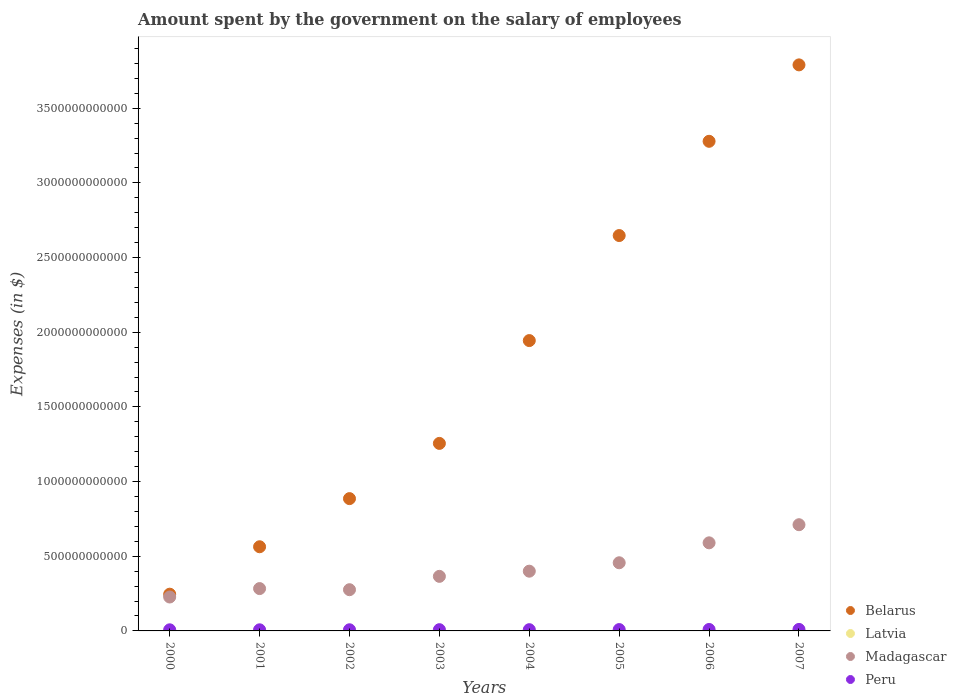How many different coloured dotlines are there?
Keep it short and to the point. 4. Is the number of dotlines equal to the number of legend labels?
Your answer should be compact. Yes. What is the amount spent on the salary of employees by the government in Peru in 2000?
Provide a succinct answer. 7.45e+09. Across all years, what is the maximum amount spent on the salary of employees by the government in Madagascar?
Offer a very short reply. 7.11e+11. Across all years, what is the minimum amount spent on the salary of employees by the government in Madagascar?
Make the answer very short. 2.27e+11. What is the total amount spent on the salary of employees by the government in Belarus in the graph?
Give a very brief answer. 1.46e+13. What is the difference between the amount spent on the salary of employees by the government in Latvia in 2001 and that in 2007?
Keep it short and to the point. -6.04e+08. What is the difference between the amount spent on the salary of employees by the government in Madagascar in 2006 and the amount spent on the salary of employees by the government in Belarus in 2007?
Give a very brief answer. -3.20e+12. What is the average amount spent on the salary of employees by the government in Peru per year?
Offer a terse response. 8.52e+09. In the year 2004, what is the difference between the amount spent on the salary of employees by the government in Madagascar and amount spent on the salary of employees by the government in Belarus?
Your answer should be very brief. -1.54e+12. What is the ratio of the amount spent on the salary of employees by the government in Peru in 2003 to that in 2005?
Your answer should be compact. 0.92. Is the amount spent on the salary of employees by the government in Peru in 2003 less than that in 2005?
Offer a very short reply. Yes. What is the difference between the highest and the second highest amount spent on the salary of employees by the government in Latvia?
Your response must be concise. 2.56e+08. What is the difference between the highest and the lowest amount spent on the salary of employees by the government in Belarus?
Provide a succinct answer. 3.54e+12. In how many years, is the amount spent on the salary of employees by the government in Belarus greater than the average amount spent on the salary of employees by the government in Belarus taken over all years?
Offer a very short reply. 4. Is it the case that in every year, the sum of the amount spent on the salary of employees by the government in Peru and amount spent on the salary of employees by the government in Latvia  is greater than the sum of amount spent on the salary of employees by the government in Belarus and amount spent on the salary of employees by the government in Madagascar?
Your response must be concise. No. Is it the case that in every year, the sum of the amount spent on the salary of employees by the government in Madagascar and amount spent on the salary of employees by the government in Peru  is greater than the amount spent on the salary of employees by the government in Belarus?
Provide a succinct answer. No. Does the amount spent on the salary of employees by the government in Peru monotonically increase over the years?
Offer a very short reply. Yes. Is the amount spent on the salary of employees by the government in Peru strictly greater than the amount spent on the salary of employees by the government in Belarus over the years?
Keep it short and to the point. No. Is the amount spent on the salary of employees by the government in Belarus strictly less than the amount spent on the salary of employees by the government in Latvia over the years?
Provide a short and direct response. No. How many years are there in the graph?
Your response must be concise. 8. What is the difference between two consecutive major ticks on the Y-axis?
Offer a very short reply. 5.00e+11. Are the values on the major ticks of Y-axis written in scientific E-notation?
Make the answer very short. No. What is the title of the graph?
Your response must be concise. Amount spent by the government on the salary of employees. Does "Morocco" appear as one of the legend labels in the graph?
Offer a terse response. No. What is the label or title of the Y-axis?
Provide a short and direct response. Expenses (in $). What is the Expenses (in $) in Belarus in 2000?
Ensure brevity in your answer.  2.46e+11. What is the Expenses (in $) of Latvia in 2000?
Offer a very short reply. 1.61e+08. What is the Expenses (in $) in Madagascar in 2000?
Give a very brief answer. 2.27e+11. What is the Expenses (in $) of Peru in 2000?
Provide a succinct answer. 7.45e+09. What is the Expenses (in $) in Belarus in 2001?
Your answer should be very brief. 5.64e+11. What is the Expenses (in $) of Latvia in 2001?
Ensure brevity in your answer.  1.73e+08. What is the Expenses (in $) of Madagascar in 2001?
Offer a terse response. 2.84e+11. What is the Expenses (in $) in Peru in 2001?
Keep it short and to the point. 7.46e+09. What is the Expenses (in $) of Belarus in 2002?
Make the answer very short. 8.86e+11. What is the Expenses (in $) of Latvia in 2002?
Make the answer very short. 2.50e+08. What is the Expenses (in $) in Madagascar in 2002?
Offer a very short reply. 2.76e+11. What is the Expenses (in $) in Peru in 2002?
Provide a short and direct response. 7.69e+09. What is the Expenses (in $) in Belarus in 2003?
Your response must be concise. 1.26e+12. What is the Expenses (in $) of Latvia in 2003?
Make the answer very short. 2.84e+08. What is the Expenses (in $) of Madagascar in 2003?
Your answer should be compact. 3.65e+11. What is the Expenses (in $) in Peru in 2003?
Provide a succinct answer. 8.31e+09. What is the Expenses (in $) of Belarus in 2004?
Offer a terse response. 1.94e+12. What is the Expenses (in $) of Latvia in 2004?
Keep it short and to the point. 3.35e+08. What is the Expenses (in $) in Madagascar in 2004?
Provide a succinct answer. 4.00e+11. What is the Expenses (in $) in Peru in 2004?
Your response must be concise. 8.36e+09. What is the Expenses (in $) of Belarus in 2005?
Keep it short and to the point. 2.65e+12. What is the Expenses (in $) of Latvia in 2005?
Provide a short and direct response. 4.13e+08. What is the Expenses (in $) of Madagascar in 2005?
Provide a succinct answer. 4.56e+11. What is the Expenses (in $) of Peru in 2005?
Offer a terse response. 9.08e+09. What is the Expenses (in $) of Belarus in 2006?
Give a very brief answer. 3.28e+12. What is the Expenses (in $) in Latvia in 2006?
Provide a short and direct response. 5.21e+08. What is the Expenses (in $) of Madagascar in 2006?
Your response must be concise. 5.90e+11. What is the Expenses (in $) in Peru in 2006?
Your response must be concise. 9.74e+09. What is the Expenses (in $) in Belarus in 2007?
Offer a terse response. 3.79e+12. What is the Expenses (in $) in Latvia in 2007?
Offer a very short reply. 7.76e+08. What is the Expenses (in $) in Madagascar in 2007?
Give a very brief answer. 7.11e+11. What is the Expenses (in $) in Peru in 2007?
Provide a succinct answer. 1.00e+1. Across all years, what is the maximum Expenses (in $) in Belarus?
Provide a succinct answer. 3.79e+12. Across all years, what is the maximum Expenses (in $) in Latvia?
Offer a terse response. 7.76e+08. Across all years, what is the maximum Expenses (in $) in Madagascar?
Your answer should be very brief. 7.11e+11. Across all years, what is the maximum Expenses (in $) of Peru?
Ensure brevity in your answer.  1.00e+1. Across all years, what is the minimum Expenses (in $) in Belarus?
Offer a terse response. 2.46e+11. Across all years, what is the minimum Expenses (in $) of Latvia?
Keep it short and to the point. 1.61e+08. Across all years, what is the minimum Expenses (in $) in Madagascar?
Provide a short and direct response. 2.27e+11. Across all years, what is the minimum Expenses (in $) of Peru?
Your response must be concise. 7.45e+09. What is the total Expenses (in $) of Belarus in the graph?
Keep it short and to the point. 1.46e+13. What is the total Expenses (in $) of Latvia in the graph?
Provide a succinct answer. 2.91e+09. What is the total Expenses (in $) of Madagascar in the graph?
Your answer should be very brief. 3.31e+12. What is the total Expenses (in $) in Peru in the graph?
Give a very brief answer. 6.81e+1. What is the difference between the Expenses (in $) in Belarus in 2000 and that in 2001?
Offer a very short reply. -3.18e+11. What is the difference between the Expenses (in $) in Latvia in 2000 and that in 2001?
Your answer should be compact. -1.14e+07. What is the difference between the Expenses (in $) of Madagascar in 2000 and that in 2001?
Offer a very short reply. -5.64e+1. What is the difference between the Expenses (in $) of Peru in 2000 and that in 2001?
Give a very brief answer. -2.60e+06. What is the difference between the Expenses (in $) of Belarus in 2000 and that in 2002?
Your response must be concise. -6.40e+11. What is the difference between the Expenses (in $) of Latvia in 2000 and that in 2002?
Your response must be concise. -8.82e+07. What is the difference between the Expenses (in $) of Madagascar in 2000 and that in 2002?
Ensure brevity in your answer.  -4.89e+1. What is the difference between the Expenses (in $) in Peru in 2000 and that in 2002?
Ensure brevity in your answer.  -2.40e+08. What is the difference between the Expenses (in $) in Belarus in 2000 and that in 2003?
Give a very brief answer. -1.01e+12. What is the difference between the Expenses (in $) in Latvia in 2000 and that in 2003?
Keep it short and to the point. -1.23e+08. What is the difference between the Expenses (in $) in Madagascar in 2000 and that in 2003?
Give a very brief answer. -1.38e+11. What is the difference between the Expenses (in $) of Peru in 2000 and that in 2003?
Your answer should be very brief. -8.55e+08. What is the difference between the Expenses (in $) in Belarus in 2000 and that in 2004?
Offer a terse response. -1.70e+12. What is the difference between the Expenses (in $) in Latvia in 2000 and that in 2004?
Ensure brevity in your answer.  -1.74e+08. What is the difference between the Expenses (in $) in Madagascar in 2000 and that in 2004?
Your response must be concise. -1.73e+11. What is the difference between the Expenses (in $) in Peru in 2000 and that in 2004?
Offer a terse response. -9.06e+08. What is the difference between the Expenses (in $) of Belarus in 2000 and that in 2005?
Your answer should be compact. -2.40e+12. What is the difference between the Expenses (in $) of Latvia in 2000 and that in 2005?
Your answer should be compact. -2.52e+08. What is the difference between the Expenses (in $) in Madagascar in 2000 and that in 2005?
Provide a short and direct response. -2.29e+11. What is the difference between the Expenses (in $) in Peru in 2000 and that in 2005?
Keep it short and to the point. -1.62e+09. What is the difference between the Expenses (in $) of Belarus in 2000 and that in 2006?
Your answer should be very brief. -3.03e+12. What is the difference between the Expenses (in $) of Latvia in 2000 and that in 2006?
Give a very brief answer. -3.60e+08. What is the difference between the Expenses (in $) of Madagascar in 2000 and that in 2006?
Give a very brief answer. -3.63e+11. What is the difference between the Expenses (in $) of Peru in 2000 and that in 2006?
Provide a short and direct response. -2.29e+09. What is the difference between the Expenses (in $) of Belarus in 2000 and that in 2007?
Ensure brevity in your answer.  -3.54e+12. What is the difference between the Expenses (in $) in Latvia in 2000 and that in 2007?
Keep it short and to the point. -6.15e+08. What is the difference between the Expenses (in $) in Madagascar in 2000 and that in 2007?
Your answer should be very brief. -4.84e+11. What is the difference between the Expenses (in $) of Peru in 2000 and that in 2007?
Provide a short and direct response. -2.59e+09. What is the difference between the Expenses (in $) of Belarus in 2001 and that in 2002?
Offer a terse response. -3.22e+11. What is the difference between the Expenses (in $) in Latvia in 2001 and that in 2002?
Provide a short and direct response. -7.69e+07. What is the difference between the Expenses (in $) of Madagascar in 2001 and that in 2002?
Ensure brevity in your answer.  7.52e+09. What is the difference between the Expenses (in $) of Peru in 2001 and that in 2002?
Make the answer very short. -2.37e+08. What is the difference between the Expenses (in $) of Belarus in 2001 and that in 2003?
Keep it short and to the point. -6.92e+11. What is the difference between the Expenses (in $) in Latvia in 2001 and that in 2003?
Your answer should be very brief. -1.11e+08. What is the difference between the Expenses (in $) of Madagascar in 2001 and that in 2003?
Your answer should be compact. -8.19e+1. What is the difference between the Expenses (in $) in Peru in 2001 and that in 2003?
Your answer should be very brief. -8.52e+08. What is the difference between the Expenses (in $) of Belarus in 2001 and that in 2004?
Your answer should be very brief. -1.38e+12. What is the difference between the Expenses (in $) in Latvia in 2001 and that in 2004?
Give a very brief answer. -1.63e+08. What is the difference between the Expenses (in $) in Madagascar in 2001 and that in 2004?
Give a very brief answer. -1.17e+11. What is the difference between the Expenses (in $) in Peru in 2001 and that in 2004?
Offer a terse response. -9.03e+08. What is the difference between the Expenses (in $) of Belarus in 2001 and that in 2005?
Provide a succinct answer. -2.08e+12. What is the difference between the Expenses (in $) in Latvia in 2001 and that in 2005?
Make the answer very short. -2.41e+08. What is the difference between the Expenses (in $) in Madagascar in 2001 and that in 2005?
Give a very brief answer. -1.73e+11. What is the difference between the Expenses (in $) in Peru in 2001 and that in 2005?
Your answer should be very brief. -1.62e+09. What is the difference between the Expenses (in $) of Belarus in 2001 and that in 2006?
Keep it short and to the point. -2.72e+12. What is the difference between the Expenses (in $) of Latvia in 2001 and that in 2006?
Provide a succinct answer. -3.48e+08. What is the difference between the Expenses (in $) of Madagascar in 2001 and that in 2006?
Keep it short and to the point. -3.06e+11. What is the difference between the Expenses (in $) of Peru in 2001 and that in 2006?
Make the answer very short. -2.29e+09. What is the difference between the Expenses (in $) in Belarus in 2001 and that in 2007?
Your response must be concise. -3.23e+12. What is the difference between the Expenses (in $) of Latvia in 2001 and that in 2007?
Make the answer very short. -6.04e+08. What is the difference between the Expenses (in $) of Madagascar in 2001 and that in 2007?
Offer a very short reply. -4.28e+11. What is the difference between the Expenses (in $) in Peru in 2001 and that in 2007?
Your answer should be compact. -2.59e+09. What is the difference between the Expenses (in $) of Belarus in 2002 and that in 2003?
Offer a terse response. -3.70e+11. What is the difference between the Expenses (in $) of Latvia in 2002 and that in 2003?
Offer a terse response. -3.44e+07. What is the difference between the Expenses (in $) of Madagascar in 2002 and that in 2003?
Keep it short and to the point. -8.94e+1. What is the difference between the Expenses (in $) in Peru in 2002 and that in 2003?
Provide a succinct answer. -6.16e+08. What is the difference between the Expenses (in $) of Belarus in 2002 and that in 2004?
Your answer should be very brief. -1.06e+12. What is the difference between the Expenses (in $) of Latvia in 2002 and that in 2004?
Give a very brief answer. -8.58e+07. What is the difference between the Expenses (in $) of Madagascar in 2002 and that in 2004?
Give a very brief answer. -1.24e+11. What is the difference between the Expenses (in $) of Peru in 2002 and that in 2004?
Make the answer very short. -6.66e+08. What is the difference between the Expenses (in $) of Belarus in 2002 and that in 2005?
Keep it short and to the point. -1.76e+12. What is the difference between the Expenses (in $) in Latvia in 2002 and that in 2005?
Your response must be concise. -1.64e+08. What is the difference between the Expenses (in $) of Madagascar in 2002 and that in 2005?
Provide a succinct answer. -1.80e+11. What is the difference between the Expenses (in $) in Peru in 2002 and that in 2005?
Your answer should be compact. -1.38e+09. What is the difference between the Expenses (in $) of Belarus in 2002 and that in 2006?
Give a very brief answer. -2.39e+12. What is the difference between the Expenses (in $) in Latvia in 2002 and that in 2006?
Offer a terse response. -2.71e+08. What is the difference between the Expenses (in $) in Madagascar in 2002 and that in 2006?
Offer a terse response. -3.14e+11. What is the difference between the Expenses (in $) in Peru in 2002 and that in 2006?
Keep it short and to the point. -2.05e+09. What is the difference between the Expenses (in $) in Belarus in 2002 and that in 2007?
Offer a terse response. -2.90e+12. What is the difference between the Expenses (in $) of Latvia in 2002 and that in 2007?
Your response must be concise. -5.27e+08. What is the difference between the Expenses (in $) of Madagascar in 2002 and that in 2007?
Provide a short and direct response. -4.35e+11. What is the difference between the Expenses (in $) of Peru in 2002 and that in 2007?
Offer a very short reply. -2.35e+09. What is the difference between the Expenses (in $) of Belarus in 2003 and that in 2004?
Ensure brevity in your answer.  -6.89e+11. What is the difference between the Expenses (in $) in Latvia in 2003 and that in 2004?
Offer a very short reply. -5.14e+07. What is the difference between the Expenses (in $) of Madagascar in 2003 and that in 2004?
Offer a very short reply. -3.46e+1. What is the difference between the Expenses (in $) of Peru in 2003 and that in 2004?
Your answer should be very brief. -5.08e+07. What is the difference between the Expenses (in $) of Belarus in 2003 and that in 2005?
Offer a very short reply. -1.39e+12. What is the difference between the Expenses (in $) of Latvia in 2003 and that in 2005?
Your answer should be very brief. -1.29e+08. What is the difference between the Expenses (in $) in Madagascar in 2003 and that in 2005?
Your response must be concise. -9.10e+1. What is the difference between the Expenses (in $) in Peru in 2003 and that in 2005?
Keep it short and to the point. -7.69e+08. What is the difference between the Expenses (in $) of Belarus in 2003 and that in 2006?
Make the answer very short. -2.02e+12. What is the difference between the Expenses (in $) of Latvia in 2003 and that in 2006?
Provide a short and direct response. -2.37e+08. What is the difference between the Expenses (in $) of Madagascar in 2003 and that in 2006?
Offer a very short reply. -2.24e+11. What is the difference between the Expenses (in $) in Peru in 2003 and that in 2006?
Keep it short and to the point. -1.43e+09. What is the difference between the Expenses (in $) in Belarus in 2003 and that in 2007?
Make the answer very short. -2.53e+12. What is the difference between the Expenses (in $) in Latvia in 2003 and that in 2007?
Ensure brevity in your answer.  -4.92e+08. What is the difference between the Expenses (in $) in Madagascar in 2003 and that in 2007?
Give a very brief answer. -3.46e+11. What is the difference between the Expenses (in $) of Peru in 2003 and that in 2007?
Provide a succinct answer. -1.74e+09. What is the difference between the Expenses (in $) of Belarus in 2004 and that in 2005?
Ensure brevity in your answer.  -7.03e+11. What is the difference between the Expenses (in $) in Latvia in 2004 and that in 2005?
Provide a short and direct response. -7.79e+07. What is the difference between the Expenses (in $) of Madagascar in 2004 and that in 2005?
Ensure brevity in your answer.  -5.64e+1. What is the difference between the Expenses (in $) in Peru in 2004 and that in 2005?
Make the answer very short. -7.18e+08. What is the difference between the Expenses (in $) of Belarus in 2004 and that in 2006?
Offer a very short reply. -1.33e+12. What is the difference between the Expenses (in $) in Latvia in 2004 and that in 2006?
Provide a short and direct response. -1.86e+08. What is the difference between the Expenses (in $) of Madagascar in 2004 and that in 2006?
Offer a very short reply. -1.90e+11. What is the difference between the Expenses (in $) of Peru in 2004 and that in 2006?
Ensure brevity in your answer.  -1.38e+09. What is the difference between the Expenses (in $) of Belarus in 2004 and that in 2007?
Your answer should be compact. -1.85e+12. What is the difference between the Expenses (in $) in Latvia in 2004 and that in 2007?
Make the answer very short. -4.41e+08. What is the difference between the Expenses (in $) of Madagascar in 2004 and that in 2007?
Provide a short and direct response. -3.11e+11. What is the difference between the Expenses (in $) of Peru in 2004 and that in 2007?
Your response must be concise. -1.69e+09. What is the difference between the Expenses (in $) in Belarus in 2005 and that in 2006?
Keep it short and to the point. -6.31e+11. What is the difference between the Expenses (in $) in Latvia in 2005 and that in 2006?
Your answer should be very brief. -1.08e+08. What is the difference between the Expenses (in $) of Madagascar in 2005 and that in 2006?
Your response must be concise. -1.34e+11. What is the difference between the Expenses (in $) in Peru in 2005 and that in 2006?
Your response must be concise. -6.66e+08. What is the difference between the Expenses (in $) of Belarus in 2005 and that in 2007?
Your response must be concise. -1.14e+12. What is the difference between the Expenses (in $) in Latvia in 2005 and that in 2007?
Ensure brevity in your answer.  -3.63e+08. What is the difference between the Expenses (in $) of Madagascar in 2005 and that in 2007?
Offer a very short reply. -2.55e+11. What is the difference between the Expenses (in $) in Peru in 2005 and that in 2007?
Offer a very short reply. -9.68e+08. What is the difference between the Expenses (in $) of Belarus in 2006 and that in 2007?
Make the answer very short. -5.12e+11. What is the difference between the Expenses (in $) of Latvia in 2006 and that in 2007?
Your answer should be very brief. -2.56e+08. What is the difference between the Expenses (in $) of Madagascar in 2006 and that in 2007?
Your answer should be compact. -1.21e+11. What is the difference between the Expenses (in $) of Peru in 2006 and that in 2007?
Your answer should be compact. -3.02e+08. What is the difference between the Expenses (in $) of Belarus in 2000 and the Expenses (in $) of Latvia in 2001?
Your answer should be very brief. 2.46e+11. What is the difference between the Expenses (in $) of Belarus in 2000 and the Expenses (in $) of Madagascar in 2001?
Your answer should be compact. -3.75e+1. What is the difference between the Expenses (in $) in Belarus in 2000 and the Expenses (in $) in Peru in 2001?
Offer a very short reply. 2.39e+11. What is the difference between the Expenses (in $) in Latvia in 2000 and the Expenses (in $) in Madagascar in 2001?
Your response must be concise. -2.83e+11. What is the difference between the Expenses (in $) in Latvia in 2000 and the Expenses (in $) in Peru in 2001?
Offer a very short reply. -7.29e+09. What is the difference between the Expenses (in $) in Madagascar in 2000 and the Expenses (in $) in Peru in 2001?
Offer a terse response. 2.20e+11. What is the difference between the Expenses (in $) of Belarus in 2000 and the Expenses (in $) of Latvia in 2002?
Your answer should be very brief. 2.46e+11. What is the difference between the Expenses (in $) of Belarus in 2000 and the Expenses (in $) of Madagascar in 2002?
Ensure brevity in your answer.  -3.00e+1. What is the difference between the Expenses (in $) of Belarus in 2000 and the Expenses (in $) of Peru in 2002?
Ensure brevity in your answer.  2.38e+11. What is the difference between the Expenses (in $) of Latvia in 2000 and the Expenses (in $) of Madagascar in 2002?
Ensure brevity in your answer.  -2.76e+11. What is the difference between the Expenses (in $) in Latvia in 2000 and the Expenses (in $) in Peru in 2002?
Provide a short and direct response. -7.53e+09. What is the difference between the Expenses (in $) in Madagascar in 2000 and the Expenses (in $) in Peru in 2002?
Give a very brief answer. 2.19e+11. What is the difference between the Expenses (in $) of Belarus in 2000 and the Expenses (in $) of Latvia in 2003?
Offer a terse response. 2.46e+11. What is the difference between the Expenses (in $) of Belarus in 2000 and the Expenses (in $) of Madagascar in 2003?
Ensure brevity in your answer.  -1.19e+11. What is the difference between the Expenses (in $) in Belarus in 2000 and the Expenses (in $) in Peru in 2003?
Offer a terse response. 2.38e+11. What is the difference between the Expenses (in $) in Latvia in 2000 and the Expenses (in $) in Madagascar in 2003?
Offer a terse response. -3.65e+11. What is the difference between the Expenses (in $) in Latvia in 2000 and the Expenses (in $) in Peru in 2003?
Provide a succinct answer. -8.15e+09. What is the difference between the Expenses (in $) of Madagascar in 2000 and the Expenses (in $) of Peru in 2003?
Provide a succinct answer. 2.19e+11. What is the difference between the Expenses (in $) of Belarus in 2000 and the Expenses (in $) of Latvia in 2004?
Ensure brevity in your answer.  2.46e+11. What is the difference between the Expenses (in $) in Belarus in 2000 and the Expenses (in $) in Madagascar in 2004?
Ensure brevity in your answer.  -1.54e+11. What is the difference between the Expenses (in $) in Belarus in 2000 and the Expenses (in $) in Peru in 2004?
Provide a succinct answer. 2.38e+11. What is the difference between the Expenses (in $) in Latvia in 2000 and the Expenses (in $) in Madagascar in 2004?
Ensure brevity in your answer.  -4.00e+11. What is the difference between the Expenses (in $) of Latvia in 2000 and the Expenses (in $) of Peru in 2004?
Your answer should be very brief. -8.20e+09. What is the difference between the Expenses (in $) in Madagascar in 2000 and the Expenses (in $) in Peru in 2004?
Provide a succinct answer. 2.19e+11. What is the difference between the Expenses (in $) of Belarus in 2000 and the Expenses (in $) of Latvia in 2005?
Provide a short and direct response. 2.46e+11. What is the difference between the Expenses (in $) of Belarus in 2000 and the Expenses (in $) of Madagascar in 2005?
Your answer should be compact. -2.10e+11. What is the difference between the Expenses (in $) in Belarus in 2000 and the Expenses (in $) in Peru in 2005?
Keep it short and to the point. 2.37e+11. What is the difference between the Expenses (in $) in Latvia in 2000 and the Expenses (in $) in Madagascar in 2005?
Offer a very short reply. -4.56e+11. What is the difference between the Expenses (in $) of Latvia in 2000 and the Expenses (in $) of Peru in 2005?
Ensure brevity in your answer.  -8.92e+09. What is the difference between the Expenses (in $) of Madagascar in 2000 and the Expenses (in $) of Peru in 2005?
Offer a terse response. 2.18e+11. What is the difference between the Expenses (in $) of Belarus in 2000 and the Expenses (in $) of Latvia in 2006?
Keep it short and to the point. 2.45e+11. What is the difference between the Expenses (in $) in Belarus in 2000 and the Expenses (in $) in Madagascar in 2006?
Offer a terse response. -3.44e+11. What is the difference between the Expenses (in $) in Belarus in 2000 and the Expenses (in $) in Peru in 2006?
Make the answer very short. 2.36e+11. What is the difference between the Expenses (in $) in Latvia in 2000 and the Expenses (in $) in Madagascar in 2006?
Offer a very short reply. -5.90e+11. What is the difference between the Expenses (in $) of Latvia in 2000 and the Expenses (in $) of Peru in 2006?
Your response must be concise. -9.58e+09. What is the difference between the Expenses (in $) of Madagascar in 2000 and the Expenses (in $) of Peru in 2006?
Keep it short and to the point. 2.17e+11. What is the difference between the Expenses (in $) in Belarus in 2000 and the Expenses (in $) in Latvia in 2007?
Your response must be concise. 2.45e+11. What is the difference between the Expenses (in $) in Belarus in 2000 and the Expenses (in $) in Madagascar in 2007?
Offer a terse response. -4.65e+11. What is the difference between the Expenses (in $) of Belarus in 2000 and the Expenses (in $) of Peru in 2007?
Offer a very short reply. 2.36e+11. What is the difference between the Expenses (in $) of Latvia in 2000 and the Expenses (in $) of Madagascar in 2007?
Your answer should be compact. -7.11e+11. What is the difference between the Expenses (in $) of Latvia in 2000 and the Expenses (in $) of Peru in 2007?
Provide a succinct answer. -9.88e+09. What is the difference between the Expenses (in $) in Madagascar in 2000 and the Expenses (in $) in Peru in 2007?
Provide a short and direct response. 2.17e+11. What is the difference between the Expenses (in $) of Belarus in 2001 and the Expenses (in $) of Latvia in 2002?
Offer a terse response. 5.63e+11. What is the difference between the Expenses (in $) of Belarus in 2001 and the Expenses (in $) of Madagascar in 2002?
Your response must be concise. 2.88e+11. What is the difference between the Expenses (in $) in Belarus in 2001 and the Expenses (in $) in Peru in 2002?
Provide a short and direct response. 5.56e+11. What is the difference between the Expenses (in $) in Latvia in 2001 and the Expenses (in $) in Madagascar in 2002?
Your response must be concise. -2.76e+11. What is the difference between the Expenses (in $) of Latvia in 2001 and the Expenses (in $) of Peru in 2002?
Make the answer very short. -7.52e+09. What is the difference between the Expenses (in $) of Madagascar in 2001 and the Expenses (in $) of Peru in 2002?
Give a very brief answer. 2.76e+11. What is the difference between the Expenses (in $) in Belarus in 2001 and the Expenses (in $) in Latvia in 2003?
Offer a terse response. 5.63e+11. What is the difference between the Expenses (in $) in Belarus in 2001 and the Expenses (in $) in Madagascar in 2003?
Offer a very short reply. 1.98e+11. What is the difference between the Expenses (in $) of Belarus in 2001 and the Expenses (in $) of Peru in 2003?
Offer a very short reply. 5.55e+11. What is the difference between the Expenses (in $) in Latvia in 2001 and the Expenses (in $) in Madagascar in 2003?
Your response must be concise. -3.65e+11. What is the difference between the Expenses (in $) in Latvia in 2001 and the Expenses (in $) in Peru in 2003?
Give a very brief answer. -8.14e+09. What is the difference between the Expenses (in $) of Madagascar in 2001 and the Expenses (in $) of Peru in 2003?
Make the answer very short. 2.75e+11. What is the difference between the Expenses (in $) in Belarus in 2001 and the Expenses (in $) in Latvia in 2004?
Make the answer very short. 5.63e+11. What is the difference between the Expenses (in $) of Belarus in 2001 and the Expenses (in $) of Madagascar in 2004?
Offer a terse response. 1.64e+11. What is the difference between the Expenses (in $) of Belarus in 2001 and the Expenses (in $) of Peru in 2004?
Your answer should be very brief. 5.55e+11. What is the difference between the Expenses (in $) in Latvia in 2001 and the Expenses (in $) in Madagascar in 2004?
Make the answer very short. -4.00e+11. What is the difference between the Expenses (in $) of Latvia in 2001 and the Expenses (in $) of Peru in 2004?
Provide a short and direct response. -8.19e+09. What is the difference between the Expenses (in $) in Madagascar in 2001 and the Expenses (in $) in Peru in 2004?
Keep it short and to the point. 2.75e+11. What is the difference between the Expenses (in $) in Belarus in 2001 and the Expenses (in $) in Latvia in 2005?
Provide a succinct answer. 5.63e+11. What is the difference between the Expenses (in $) of Belarus in 2001 and the Expenses (in $) of Madagascar in 2005?
Keep it short and to the point. 1.07e+11. What is the difference between the Expenses (in $) in Belarus in 2001 and the Expenses (in $) in Peru in 2005?
Your answer should be compact. 5.55e+11. What is the difference between the Expenses (in $) in Latvia in 2001 and the Expenses (in $) in Madagascar in 2005?
Keep it short and to the point. -4.56e+11. What is the difference between the Expenses (in $) in Latvia in 2001 and the Expenses (in $) in Peru in 2005?
Give a very brief answer. -8.90e+09. What is the difference between the Expenses (in $) of Madagascar in 2001 and the Expenses (in $) of Peru in 2005?
Ensure brevity in your answer.  2.74e+11. What is the difference between the Expenses (in $) in Belarus in 2001 and the Expenses (in $) in Latvia in 2006?
Provide a short and direct response. 5.63e+11. What is the difference between the Expenses (in $) of Belarus in 2001 and the Expenses (in $) of Madagascar in 2006?
Your answer should be compact. -2.63e+1. What is the difference between the Expenses (in $) in Belarus in 2001 and the Expenses (in $) in Peru in 2006?
Offer a very short reply. 5.54e+11. What is the difference between the Expenses (in $) in Latvia in 2001 and the Expenses (in $) in Madagascar in 2006?
Provide a succinct answer. -5.90e+11. What is the difference between the Expenses (in $) of Latvia in 2001 and the Expenses (in $) of Peru in 2006?
Provide a short and direct response. -9.57e+09. What is the difference between the Expenses (in $) of Madagascar in 2001 and the Expenses (in $) of Peru in 2006?
Offer a terse response. 2.74e+11. What is the difference between the Expenses (in $) of Belarus in 2001 and the Expenses (in $) of Latvia in 2007?
Provide a short and direct response. 5.63e+11. What is the difference between the Expenses (in $) of Belarus in 2001 and the Expenses (in $) of Madagascar in 2007?
Provide a short and direct response. -1.48e+11. What is the difference between the Expenses (in $) in Belarus in 2001 and the Expenses (in $) in Peru in 2007?
Keep it short and to the point. 5.54e+11. What is the difference between the Expenses (in $) in Latvia in 2001 and the Expenses (in $) in Madagascar in 2007?
Make the answer very short. -7.11e+11. What is the difference between the Expenses (in $) in Latvia in 2001 and the Expenses (in $) in Peru in 2007?
Your answer should be compact. -9.87e+09. What is the difference between the Expenses (in $) in Madagascar in 2001 and the Expenses (in $) in Peru in 2007?
Ensure brevity in your answer.  2.73e+11. What is the difference between the Expenses (in $) in Belarus in 2002 and the Expenses (in $) in Latvia in 2003?
Give a very brief answer. 8.86e+11. What is the difference between the Expenses (in $) of Belarus in 2002 and the Expenses (in $) of Madagascar in 2003?
Make the answer very short. 5.21e+11. What is the difference between the Expenses (in $) of Belarus in 2002 and the Expenses (in $) of Peru in 2003?
Your answer should be very brief. 8.78e+11. What is the difference between the Expenses (in $) in Latvia in 2002 and the Expenses (in $) in Madagascar in 2003?
Your answer should be very brief. -3.65e+11. What is the difference between the Expenses (in $) in Latvia in 2002 and the Expenses (in $) in Peru in 2003?
Give a very brief answer. -8.06e+09. What is the difference between the Expenses (in $) in Madagascar in 2002 and the Expenses (in $) in Peru in 2003?
Offer a terse response. 2.68e+11. What is the difference between the Expenses (in $) in Belarus in 2002 and the Expenses (in $) in Latvia in 2004?
Keep it short and to the point. 8.86e+11. What is the difference between the Expenses (in $) of Belarus in 2002 and the Expenses (in $) of Madagascar in 2004?
Give a very brief answer. 4.86e+11. What is the difference between the Expenses (in $) of Belarus in 2002 and the Expenses (in $) of Peru in 2004?
Give a very brief answer. 8.78e+11. What is the difference between the Expenses (in $) in Latvia in 2002 and the Expenses (in $) in Madagascar in 2004?
Offer a very short reply. -4.00e+11. What is the difference between the Expenses (in $) in Latvia in 2002 and the Expenses (in $) in Peru in 2004?
Ensure brevity in your answer.  -8.11e+09. What is the difference between the Expenses (in $) of Madagascar in 2002 and the Expenses (in $) of Peru in 2004?
Your response must be concise. 2.68e+11. What is the difference between the Expenses (in $) of Belarus in 2002 and the Expenses (in $) of Latvia in 2005?
Provide a short and direct response. 8.86e+11. What is the difference between the Expenses (in $) in Belarus in 2002 and the Expenses (in $) in Madagascar in 2005?
Provide a short and direct response. 4.30e+11. What is the difference between the Expenses (in $) of Belarus in 2002 and the Expenses (in $) of Peru in 2005?
Provide a short and direct response. 8.77e+11. What is the difference between the Expenses (in $) of Latvia in 2002 and the Expenses (in $) of Madagascar in 2005?
Offer a very short reply. -4.56e+11. What is the difference between the Expenses (in $) in Latvia in 2002 and the Expenses (in $) in Peru in 2005?
Offer a terse response. -8.83e+09. What is the difference between the Expenses (in $) in Madagascar in 2002 and the Expenses (in $) in Peru in 2005?
Give a very brief answer. 2.67e+11. What is the difference between the Expenses (in $) in Belarus in 2002 and the Expenses (in $) in Latvia in 2006?
Provide a short and direct response. 8.85e+11. What is the difference between the Expenses (in $) of Belarus in 2002 and the Expenses (in $) of Madagascar in 2006?
Make the answer very short. 2.96e+11. What is the difference between the Expenses (in $) in Belarus in 2002 and the Expenses (in $) in Peru in 2006?
Keep it short and to the point. 8.76e+11. What is the difference between the Expenses (in $) in Latvia in 2002 and the Expenses (in $) in Madagascar in 2006?
Your answer should be compact. -5.90e+11. What is the difference between the Expenses (in $) in Latvia in 2002 and the Expenses (in $) in Peru in 2006?
Your answer should be compact. -9.49e+09. What is the difference between the Expenses (in $) of Madagascar in 2002 and the Expenses (in $) of Peru in 2006?
Ensure brevity in your answer.  2.66e+11. What is the difference between the Expenses (in $) in Belarus in 2002 and the Expenses (in $) in Latvia in 2007?
Your answer should be compact. 8.85e+11. What is the difference between the Expenses (in $) of Belarus in 2002 and the Expenses (in $) of Madagascar in 2007?
Make the answer very short. 1.75e+11. What is the difference between the Expenses (in $) of Belarus in 2002 and the Expenses (in $) of Peru in 2007?
Keep it short and to the point. 8.76e+11. What is the difference between the Expenses (in $) of Latvia in 2002 and the Expenses (in $) of Madagascar in 2007?
Keep it short and to the point. -7.11e+11. What is the difference between the Expenses (in $) in Latvia in 2002 and the Expenses (in $) in Peru in 2007?
Ensure brevity in your answer.  -9.80e+09. What is the difference between the Expenses (in $) in Madagascar in 2002 and the Expenses (in $) in Peru in 2007?
Provide a short and direct response. 2.66e+11. What is the difference between the Expenses (in $) in Belarus in 2003 and the Expenses (in $) in Latvia in 2004?
Give a very brief answer. 1.26e+12. What is the difference between the Expenses (in $) in Belarus in 2003 and the Expenses (in $) in Madagascar in 2004?
Keep it short and to the point. 8.56e+11. What is the difference between the Expenses (in $) in Belarus in 2003 and the Expenses (in $) in Peru in 2004?
Provide a short and direct response. 1.25e+12. What is the difference between the Expenses (in $) of Latvia in 2003 and the Expenses (in $) of Madagascar in 2004?
Make the answer very short. -4.00e+11. What is the difference between the Expenses (in $) of Latvia in 2003 and the Expenses (in $) of Peru in 2004?
Your answer should be very brief. -8.08e+09. What is the difference between the Expenses (in $) in Madagascar in 2003 and the Expenses (in $) in Peru in 2004?
Make the answer very short. 3.57e+11. What is the difference between the Expenses (in $) of Belarus in 2003 and the Expenses (in $) of Latvia in 2005?
Give a very brief answer. 1.26e+12. What is the difference between the Expenses (in $) in Belarus in 2003 and the Expenses (in $) in Madagascar in 2005?
Ensure brevity in your answer.  7.99e+11. What is the difference between the Expenses (in $) of Belarus in 2003 and the Expenses (in $) of Peru in 2005?
Offer a terse response. 1.25e+12. What is the difference between the Expenses (in $) of Latvia in 2003 and the Expenses (in $) of Madagascar in 2005?
Keep it short and to the point. -4.56e+11. What is the difference between the Expenses (in $) of Latvia in 2003 and the Expenses (in $) of Peru in 2005?
Offer a terse response. -8.79e+09. What is the difference between the Expenses (in $) of Madagascar in 2003 and the Expenses (in $) of Peru in 2005?
Provide a short and direct response. 3.56e+11. What is the difference between the Expenses (in $) of Belarus in 2003 and the Expenses (in $) of Latvia in 2006?
Provide a short and direct response. 1.26e+12. What is the difference between the Expenses (in $) in Belarus in 2003 and the Expenses (in $) in Madagascar in 2006?
Provide a short and direct response. 6.66e+11. What is the difference between the Expenses (in $) in Belarus in 2003 and the Expenses (in $) in Peru in 2006?
Provide a succinct answer. 1.25e+12. What is the difference between the Expenses (in $) of Latvia in 2003 and the Expenses (in $) of Madagascar in 2006?
Make the answer very short. -5.90e+11. What is the difference between the Expenses (in $) in Latvia in 2003 and the Expenses (in $) in Peru in 2006?
Your answer should be very brief. -9.46e+09. What is the difference between the Expenses (in $) of Madagascar in 2003 and the Expenses (in $) of Peru in 2006?
Your response must be concise. 3.56e+11. What is the difference between the Expenses (in $) of Belarus in 2003 and the Expenses (in $) of Latvia in 2007?
Provide a succinct answer. 1.25e+12. What is the difference between the Expenses (in $) of Belarus in 2003 and the Expenses (in $) of Madagascar in 2007?
Your answer should be compact. 5.45e+11. What is the difference between the Expenses (in $) in Belarus in 2003 and the Expenses (in $) in Peru in 2007?
Offer a terse response. 1.25e+12. What is the difference between the Expenses (in $) in Latvia in 2003 and the Expenses (in $) in Madagascar in 2007?
Your response must be concise. -7.11e+11. What is the difference between the Expenses (in $) of Latvia in 2003 and the Expenses (in $) of Peru in 2007?
Make the answer very short. -9.76e+09. What is the difference between the Expenses (in $) in Madagascar in 2003 and the Expenses (in $) in Peru in 2007?
Keep it short and to the point. 3.55e+11. What is the difference between the Expenses (in $) in Belarus in 2004 and the Expenses (in $) in Latvia in 2005?
Offer a terse response. 1.94e+12. What is the difference between the Expenses (in $) of Belarus in 2004 and the Expenses (in $) of Madagascar in 2005?
Keep it short and to the point. 1.49e+12. What is the difference between the Expenses (in $) in Belarus in 2004 and the Expenses (in $) in Peru in 2005?
Your answer should be compact. 1.94e+12. What is the difference between the Expenses (in $) of Latvia in 2004 and the Expenses (in $) of Madagascar in 2005?
Your answer should be very brief. -4.56e+11. What is the difference between the Expenses (in $) of Latvia in 2004 and the Expenses (in $) of Peru in 2005?
Keep it short and to the point. -8.74e+09. What is the difference between the Expenses (in $) of Madagascar in 2004 and the Expenses (in $) of Peru in 2005?
Give a very brief answer. 3.91e+11. What is the difference between the Expenses (in $) of Belarus in 2004 and the Expenses (in $) of Latvia in 2006?
Your answer should be compact. 1.94e+12. What is the difference between the Expenses (in $) in Belarus in 2004 and the Expenses (in $) in Madagascar in 2006?
Your answer should be compact. 1.35e+12. What is the difference between the Expenses (in $) of Belarus in 2004 and the Expenses (in $) of Peru in 2006?
Keep it short and to the point. 1.93e+12. What is the difference between the Expenses (in $) of Latvia in 2004 and the Expenses (in $) of Madagascar in 2006?
Your response must be concise. -5.90e+11. What is the difference between the Expenses (in $) of Latvia in 2004 and the Expenses (in $) of Peru in 2006?
Provide a short and direct response. -9.41e+09. What is the difference between the Expenses (in $) in Madagascar in 2004 and the Expenses (in $) in Peru in 2006?
Offer a terse response. 3.90e+11. What is the difference between the Expenses (in $) of Belarus in 2004 and the Expenses (in $) of Latvia in 2007?
Provide a short and direct response. 1.94e+12. What is the difference between the Expenses (in $) of Belarus in 2004 and the Expenses (in $) of Madagascar in 2007?
Ensure brevity in your answer.  1.23e+12. What is the difference between the Expenses (in $) of Belarus in 2004 and the Expenses (in $) of Peru in 2007?
Offer a terse response. 1.93e+12. What is the difference between the Expenses (in $) of Latvia in 2004 and the Expenses (in $) of Madagascar in 2007?
Offer a very short reply. -7.11e+11. What is the difference between the Expenses (in $) in Latvia in 2004 and the Expenses (in $) in Peru in 2007?
Your response must be concise. -9.71e+09. What is the difference between the Expenses (in $) of Madagascar in 2004 and the Expenses (in $) of Peru in 2007?
Keep it short and to the point. 3.90e+11. What is the difference between the Expenses (in $) in Belarus in 2005 and the Expenses (in $) in Latvia in 2006?
Provide a short and direct response. 2.65e+12. What is the difference between the Expenses (in $) in Belarus in 2005 and the Expenses (in $) in Madagascar in 2006?
Give a very brief answer. 2.06e+12. What is the difference between the Expenses (in $) in Belarus in 2005 and the Expenses (in $) in Peru in 2006?
Ensure brevity in your answer.  2.64e+12. What is the difference between the Expenses (in $) of Latvia in 2005 and the Expenses (in $) of Madagascar in 2006?
Your response must be concise. -5.89e+11. What is the difference between the Expenses (in $) of Latvia in 2005 and the Expenses (in $) of Peru in 2006?
Ensure brevity in your answer.  -9.33e+09. What is the difference between the Expenses (in $) in Madagascar in 2005 and the Expenses (in $) in Peru in 2006?
Give a very brief answer. 4.47e+11. What is the difference between the Expenses (in $) of Belarus in 2005 and the Expenses (in $) of Latvia in 2007?
Your answer should be very brief. 2.65e+12. What is the difference between the Expenses (in $) in Belarus in 2005 and the Expenses (in $) in Madagascar in 2007?
Make the answer very short. 1.94e+12. What is the difference between the Expenses (in $) of Belarus in 2005 and the Expenses (in $) of Peru in 2007?
Ensure brevity in your answer.  2.64e+12. What is the difference between the Expenses (in $) of Latvia in 2005 and the Expenses (in $) of Madagascar in 2007?
Ensure brevity in your answer.  -7.11e+11. What is the difference between the Expenses (in $) of Latvia in 2005 and the Expenses (in $) of Peru in 2007?
Your answer should be very brief. -9.63e+09. What is the difference between the Expenses (in $) in Madagascar in 2005 and the Expenses (in $) in Peru in 2007?
Give a very brief answer. 4.46e+11. What is the difference between the Expenses (in $) of Belarus in 2006 and the Expenses (in $) of Latvia in 2007?
Keep it short and to the point. 3.28e+12. What is the difference between the Expenses (in $) in Belarus in 2006 and the Expenses (in $) in Madagascar in 2007?
Provide a succinct answer. 2.57e+12. What is the difference between the Expenses (in $) in Belarus in 2006 and the Expenses (in $) in Peru in 2007?
Ensure brevity in your answer.  3.27e+12. What is the difference between the Expenses (in $) of Latvia in 2006 and the Expenses (in $) of Madagascar in 2007?
Offer a terse response. -7.11e+11. What is the difference between the Expenses (in $) of Latvia in 2006 and the Expenses (in $) of Peru in 2007?
Offer a terse response. -9.52e+09. What is the difference between the Expenses (in $) of Madagascar in 2006 and the Expenses (in $) of Peru in 2007?
Offer a terse response. 5.80e+11. What is the average Expenses (in $) in Belarus per year?
Provide a short and direct response. 1.83e+12. What is the average Expenses (in $) of Latvia per year?
Your response must be concise. 3.64e+08. What is the average Expenses (in $) of Madagascar per year?
Offer a very short reply. 4.14e+11. What is the average Expenses (in $) of Peru per year?
Offer a terse response. 8.52e+09. In the year 2000, what is the difference between the Expenses (in $) of Belarus and Expenses (in $) of Latvia?
Offer a terse response. 2.46e+11. In the year 2000, what is the difference between the Expenses (in $) in Belarus and Expenses (in $) in Madagascar?
Your answer should be very brief. 1.89e+1. In the year 2000, what is the difference between the Expenses (in $) in Belarus and Expenses (in $) in Peru?
Keep it short and to the point. 2.39e+11. In the year 2000, what is the difference between the Expenses (in $) of Latvia and Expenses (in $) of Madagascar?
Provide a short and direct response. -2.27e+11. In the year 2000, what is the difference between the Expenses (in $) of Latvia and Expenses (in $) of Peru?
Your response must be concise. -7.29e+09. In the year 2000, what is the difference between the Expenses (in $) of Madagascar and Expenses (in $) of Peru?
Your answer should be compact. 2.20e+11. In the year 2001, what is the difference between the Expenses (in $) of Belarus and Expenses (in $) of Latvia?
Give a very brief answer. 5.63e+11. In the year 2001, what is the difference between the Expenses (in $) in Belarus and Expenses (in $) in Madagascar?
Keep it short and to the point. 2.80e+11. In the year 2001, what is the difference between the Expenses (in $) of Belarus and Expenses (in $) of Peru?
Your response must be concise. 5.56e+11. In the year 2001, what is the difference between the Expenses (in $) in Latvia and Expenses (in $) in Madagascar?
Your answer should be very brief. -2.83e+11. In the year 2001, what is the difference between the Expenses (in $) in Latvia and Expenses (in $) in Peru?
Your response must be concise. -7.28e+09. In the year 2001, what is the difference between the Expenses (in $) of Madagascar and Expenses (in $) of Peru?
Your response must be concise. 2.76e+11. In the year 2002, what is the difference between the Expenses (in $) in Belarus and Expenses (in $) in Latvia?
Your answer should be compact. 8.86e+11. In the year 2002, what is the difference between the Expenses (in $) in Belarus and Expenses (in $) in Madagascar?
Make the answer very short. 6.10e+11. In the year 2002, what is the difference between the Expenses (in $) of Belarus and Expenses (in $) of Peru?
Make the answer very short. 8.78e+11. In the year 2002, what is the difference between the Expenses (in $) of Latvia and Expenses (in $) of Madagascar?
Give a very brief answer. -2.76e+11. In the year 2002, what is the difference between the Expenses (in $) of Latvia and Expenses (in $) of Peru?
Provide a short and direct response. -7.44e+09. In the year 2002, what is the difference between the Expenses (in $) of Madagascar and Expenses (in $) of Peru?
Ensure brevity in your answer.  2.68e+11. In the year 2003, what is the difference between the Expenses (in $) of Belarus and Expenses (in $) of Latvia?
Provide a succinct answer. 1.26e+12. In the year 2003, what is the difference between the Expenses (in $) in Belarus and Expenses (in $) in Madagascar?
Offer a terse response. 8.90e+11. In the year 2003, what is the difference between the Expenses (in $) in Belarus and Expenses (in $) in Peru?
Make the answer very short. 1.25e+12. In the year 2003, what is the difference between the Expenses (in $) in Latvia and Expenses (in $) in Madagascar?
Offer a very short reply. -3.65e+11. In the year 2003, what is the difference between the Expenses (in $) of Latvia and Expenses (in $) of Peru?
Make the answer very short. -8.02e+09. In the year 2003, what is the difference between the Expenses (in $) in Madagascar and Expenses (in $) in Peru?
Give a very brief answer. 3.57e+11. In the year 2004, what is the difference between the Expenses (in $) in Belarus and Expenses (in $) in Latvia?
Make the answer very short. 1.94e+12. In the year 2004, what is the difference between the Expenses (in $) in Belarus and Expenses (in $) in Madagascar?
Provide a short and direct response. 1.54e+12. In the year 2004, what is the difference between the Expenses (in $) in Belarus and Expenses (in $) in Peru?
Provide a short and direct response. 1.94e+12. In the year 2004, what is the difference between the Expenses (in $) of Latvia and Expenses (in $) of Madagascar?
Offer a very short reply. -4.00e+11. In the year 2004, what is the difference between the Expenses (in $) in Latvia and Expenses (in $) in Peru?
Keep it short and to the point. -8.02e+09. In the year 2004, what is the difference between the Expenses (in $) in Madagascar and Expenses (in $) in Peru?
Provide a short and direct response. 3.92e+11. In the year 2005, what is the difference between the Expenses (in $) in Belarus and Expenses (in $) in Latvia?
Make the answer very short. 2.65e+12. In the year 2005, what is the difference between the Expenses (in $) of Belarus and Expenses (in $) of Madagascar?
Offer a terse response. 2.19e+12. In the year 2005, what is the difference between the Expenses (in $) of Belarus and Expenses (in $) of Peru?
Your answer should be compact. 2.64e+12. In the year 2005, what is the difference between the Expenses (in $) of Latvia and Expenses (in $) of Madagascar?
Give a very brief answer. -4.56e+11. In the year 2005, what is the difference between the Expenses (in $) of Latvia and Expenses (in $) of Peru?
Ensure brevity in your answer.  -8.66e+09. In the year 2005, what is the difference between the Expenses (in $) of Madagascar and Expenses (in $) of Peru?
Give a very brief answer. 4.47e+11. In the year 2006, what is the difference between the Expenses (in $) of Belarus and Expenses (in $) of Latvia?
Keep it short and to the point. 3.28e+12. In the year 2006, what is the difference between the Expenses (in $) in Belarus and Expenses (in $) in Madagascar?
Make the answer very short. 2.69e+12. In the year 2006, what is the difference between the Expenses (in $) in Belarus and Expenses (in $) in Peru?
Offer a very short reply. 3.27e+12. In the year 2006, what is the difference between the Expenses (in $) in Latvia and Expenses (in $) in Madagascar?
Keep it short and to the point. -5.89e+11. In the year 2006, what is the difference between the Expenses (in $) in Latvia and Expenses (in $) in Peru?
Keep it short and to the point. -9.22e+09. In the year 2006, what is the difference between the Expenses (in $) in Madagascar and Expenses (in $) in Peru?
Offer a very short reply. 5.80e+11. In the year 2007, what is the difference between the Expenses (in $) of Belarus and Expenses (in $) of Latvia?
Offer a very short reply. 3.79e+12. In the year 2007, what is the difference between the Expenses (in $) in Belarus and Expenses (in $) in Madagascar?
Ensure brevity in your answer.  3.08e+12. In the year 2007, what is the difference between the Expenses (in $) of Belarus and Expenses (in $) of Peru?
Your response must be concise. 3.78e+12. In the year 2007, what is the difference between the Expenses (in $) in Latvia and Expenses (in $) in Madagascar?
Offer a terse response. -7.10e+11. In the year 2007, what is the difference between the Expenses (in $) in Latvia and Expenses (in $) in Peru?
Your answer should be very brief. -9.27e+09. In the year 2007, what is the difference between the Expenses (in $) of Madagascar and Expenses (in $) of Peru?
Offer a terse response. 7.01e+11. What is the ratio of the Expenses (in $) of Belarus in 2000 to that in 2001?
Make the answer very short. 0.44. What is the ratio of the Expenses (in $) in Latvia in 2000 to that in 2001?
Give a very brief answer. 0.93. What is the ratio of the Expenses (in $) in Madagascar in 2000 to that in 2001?
Your response must be concise. 0.8. What is the ratio of the Expenses (in $) of Peru in 2000 to that in 2001?
Your answer should be very brief. 1. What is the ratio of the Expenses (in $) in Belarus in 2000 to that in 2002?
Provide a short and direct response. 0.28. What is the ratio of the Expenses (in $) of Latvia in 2000 to that in 2002?
Your response must be concise. 0.65. What is the ratio of the Expenses (in $) of Madagascar in 2000 to that in 2002?
Give a very brief answer. 0.82. What is the ratio of the Expenses (in $) of Peru in 2000 to that in 2002?
Offer a terse response. 0.97. What is the ratio of the Expenses (in $) of Belarus in 2000 to that in 2003?
Provide a succinct answer. 0.2. What is the ratio of the Expenses (in $) in Latvia in 2000 to that in 2003?
Ensure brevity in your answer.  0.57. What is the ratio of the Expenses (in $) in Madagascar in 2000 to that in 2003?
Your response must be concise. 0.62. What is the ratio of the Expenses (in $) in Peru in 2000 to that in 2003?
Make the answer very short. 0.9. What is the ratio of the Expenses (in $) in Belarus in 2000 to that in 2004?
Your answer should be compact. 0.13. What is the ratio of the Expenses (in $) of Latvia in 2000 to that in 2004?
Ensure brevity in your answer.  0.48. What is the ratio of the Expenses (in $) in Madagascar in 2000 to that in 2004?
Keep it short and to the point. 0.57. What is the ratio of the Expenses (in $) of Peru in 2000 to that in 2004?
Make the answer very short. 0.89. What is the ratio of the Expenses (in $) in Belarus in 2000 to that in 2005?
Your response must be concise. 0.09. What is the ratio of the Expenses (in $) of Latvia in 2000 to that in 2005?
Provide a succinct answer. 0.39. What is the ratio of the Expenses (in $) in Madagascar in 2000 to that in 2005?
Your answer should be compact. 0.5. What is the ratio of the Expenses (in $) of Peru in 2000 to that in 2005?
Make the answer very short. 0.82. What is the ratio of the Expenses (in $) of Belarus in 2000 to that in 2006?
Make the answer very short. 0.07. What is the ratio of the Expenses (in $) of Latvia in 2000 to that in 2006?
Your answer should be compact. 0.31. What is the ratio of the Expenses (in $) of Madagascar in 2000 to that in 2006?
Your answer should be very brief. 0.38. What is the ratio of the Expenses (in $) in Peru in 2000 to that in 2006?
Keep it short and to the point. 0.77. What is the ratio of the Expenses (in $) in Belarus in 2000 to that in 2007?
Offer a terse response. 0.06. What is the ratio of the Expenses (in $) in Latvia in 2000 to that in 2007?
Keep it short and to the point. 0.21. What is the ratio of the Expenses (in $) in Madagascar in 2000 to that in 2007?
Offer a very short reply. 0.32. What is the ratio of the Expenses (in $) of Peru in 2000 to that in 2007?
Ensure brevity in your answer.  0.74. What is the ratio of the Expenses (in $) of Belarus in 2001 to that in 2002?
Your answer should be very brief. 0.64. What is the ratio of the Expenses (in $) in Latvia in 2001 to that in 2002?
Provide a short and direct response. 0.69. What is the ratio of the Expenses (in $) in Madagascar in 2001 to that in 2002?
Offer a terse response. 1.03. What is the ratio of the Expenses (in $) of Peru in 2001 to that in 2002?
Provide a succinct answer. 0.97. What is the ratio of the Expenses (in $) in Belarus in 2001 to that in 2003?
Your answer should be compact. 0.45. What is the ratio of the Expenses (in $) of Latvia in 2001 to that in 2003?
Ensure brevity in your answer.  0.61. What is the ratio of the Expenses (in $) in Madagascar in 2001 to that in 2003?
Give a very brief answer. 0.78. What is the ratio of the Expenses (in $) in Peru in 2001 to that in 2003?
Ensure brevity in your answer.  0.9. What is the ratio of the Expenses (in $) of Belarus in 2001 to that in 2004?
Give a very brief answer. 0.29. What is the ratio of the Expenses (in $) in Latvia in 2001 to that in 2004?
Keep it short and to the point. 0.51. What is the ratio of the Expenses (in $) in Madagascar in 2001 to that in 2004?
Provide a short and direct response. 0.71. What is the ratio of the Expenses (in $) of Peru in 2001 to that in 2004?
Keep it short and to the point. 0.89. What is the ratio of the Expenses (in $) in Belarus in 2001 to that in 2005?
Your answer should be compact. 0.21. What is the ratio of the Expenses (in $) of Latvia in 2001 to that in 2005?
Your answer should be compact. 0.42. What is the ratio of the Expenses (in $) of Madagascar in 2001 to that in 2005?
Offer a very short reply. 0.62. What is the ratio of the Expenses (in $) of Peru in 2001 to that in 2005?
Your answer should be compact. 0.82. What is the ratio of the Expenses (in $) in Belarus in 2001 to that in 2006?
Make the answer very short. 0.17. What is the ratio of the Expenses (in $) of Latvia in 2001 to that in 2006?
Offer a terse response. 0.33. What is the ratio of the Expenses (in $) of Madagascar in 2001 to that in 2006?
Your response must be concise. 0.48. What is the ratio of the Expenses (in $) in Peru in 2001 to that in 2006?
Provide a short and direct response. 0.77. What is the ratio of the Expenses (in $) of Belarus in 2001 to that in 2007?
Your answer should be very brief. 0.15. What is the ratio of the Expenses (in $) in Latvia in 2001 to that in 2007?
Ensure brevity in your answer.  0.22. What is the ratio of the Expenses (in $) in Madagascar in 2001 to that in 2007?
Provide a succinct answer. 0.4. What is the ratio of the Expenses (in $) of Peru in 2001 to that in 2007?
Give a very brief answer. 0.74. What is the ratio of the Expenses (in $) in Belarus in 2002 to that in 2003?
Offer a terse response. 0.71. What is the ratio of the Expenses (in $) in Latvia in 2002 to that in 2003?
Ensure brevity in your answer.  0.88. What is the ratio of the Expenses (in $) of Madagascar in 2002 to that in 2003?
Provide a short and direct response. 0.76. What is the ratio of the Expenses (in $) of Peru in 2002 to that in 2003?
Offer a terse response. 0.93. What is the ratio of the Expenses (in $) of Belarus in 2002 to that in 2004?
Provide a short and direct response. 0.46. What is the ratio of the Expenses (in $) in Latvia in 2002 to that in 2004?
Offer a very short reply. 0.74. What is the ratio of the Expenses (in $) in Madagascar in 2002 to that in 2004?
Make the answer very short. 0.69. What is the ratio of the Expenses (in $) of Peru in 2002 to that in 2004?
Offer a very short reply. 0.92. What is the ratio of the Expenses (in $) of Belarus in 2002 to that in 2005?
Offer a terse response. 0.33. What is the ratio of the Expenses (in $) of Latvia in 2002 to that in 2005?
Offer a very short reply. 0.6. What is the ratio of the Expenses (in $) in Madagascar in 2002 to that in 2005?
Keep it short and to the point. 0.6. What is the ratio of the Expenses (in $) in Peru in 2002 to that in 2005?
Offer a very short reply. 0.85. What is the ratio of the Expenses (in $) in Belarus in 2002 to that in 2006?
Ensure brevity in your answer.  0.27. What is the ratio of the Expenses (in $) of Latvia in 2002 to that in 2006?
Give a very brief answer. 0.48. What is the ratio of the Expenses (in $) of Madagascar in 2002 to that in 2006?
Your answer should be very brief. 0.47. What is the ratio of the Expenses (in $) in Peru in 2002 to that in 2006?
Offer a terse response. 0.79. What is the ratio of the Expenses (in $) in Belarus in 2002 to that in 2007?
Give a very brief answer. 0.23. What is the ratio of the Expenses (in $) in Latvia in 2002 to that in 2007?
Offer a terse response. 0.32. What is the ratio of the Expenses (in $) of Madagascar in 2002 to that in 2007?
Offer a terse response. 0.39. What is the ratio of the Expenses (in $) in Peru in 2002 to that in 2007?
Your answer should be compact. 0.77. What is the ratio of the Expenses (in $) in Belarus in 2003 to that in 2004?
Keep it short and to the point. 0.65. What is the ratio of the Expenses (in $) in Latvia in 2003 to that in 2004?
Keep it short and to the point. 0.85. What is the ratio of the Expenses (in $) in Madagascar in 2003 to that in 2004?
Your response must be concise. 0.91. What is the ratio of the Expenses (in $) in Peru in 2003 to that in 2004?
Your answer should be compact. 0.99. What is the ratio of the Expenses (in $) of Belarus in 2003 to that in 2005?
Your response must be concise. 0.47. What is the ratio of the Expenses (in $) of Latvia in 2003 to that in 2005?
Provide a short and direct response. 0.69. What is the ratio of the Expenses (in $) of Madagascar in 2003 to that in 2005?
Your answer should be compact. 0.8. What is the ratio of the Expenses (in $) in Peru in 2003 to that in 2005?
Offer a very short reply. 0.92. What is the ratio of the Expenses (in $) in Belarus in 2003 to that in 2006?
Make the answer very short. 0.38. What is the ratio of the Expenses (in $) in Latvia in 2003 to that in 2006?
Make the answer very short. 0.55. What is the ratio of the Expenses (in $) of Madagascar in 2003 to that in 2006?
Make the answer very short. 0.62. What is the ratio of the Expenses (in $) of Peru in 2003 to that in 2006?
Provide a succinct answer. 0.85. What is the ratio of the Expenses (in $) of Belarus in 2003 to that in 2007?
Ensure brevity in your answer.  0.33. What is the ratio of the Expenses (in $) in Latvia in 2003 to that in 2007?
Offer a terse response. 0.37. What is the ratio of the Expenses (in $) in Madagascar in 2003 to that in 2007?
Offer a terse response. 0.51. What is the ratio of the Expenses (in $) in Peru in 2003 to that in 2007?
Give a very brief answer. 0.83. What is the ratio of the Expenses (in $) of Belarus in 2004 to that in 2005?
Offer a very short reply. 0.73. What is the ratio of the Expenses (in $) in Latvia in 2004 to that in 2005?
Provide a short and direct response. 0.81. What is the ratio of the Expenses (in $) in Madagascar in 2004 to that in 2005?
Give a very brief answer. 0.88. What is the ratio of the Expenses (in $) in Peru in 2004 to that in 2005?
Provide a succinct answer. 0.92. What is the ratio of the Expenses (in $) in Belarus in 2004 to that in 2006?
Your answer should be very brief. 0.59. What is the ratio of the Expenses (in $) in Latvia in 2004 to that in 2006?
Offer a very short reply. 0.64. What is the ratio of the Expenses (in $) of Madagascar in 2004 to that in 2006?
Make the answer very short. 0.68. What is the ratio of the Expenses (in $) in Peru in 2004 to that in 2006?
Your answer should be compact. 0.86. What is the ratio of the Expenses (in $) in Belarus in 2004 to that in 2007?
Your answer should be compact. 0.51. What is the ratio of the Expenses (in $) of Latvia in 2004 to that in 2007?
Keep it short and to the point. 0.43. What is the ratio of the Expenses (in $) in Madagascar in 2004 to that in 2007?
Make the answer very short. 0.56. What is the ratio of the Expenses (in $) in Peru in 2004 to that in 2007?
Your response must be concise. 0.83. What is the ratio of the Expenses (in $) in Belarus in 2005 to that in 2006?
Make the answer very short. 0.81. What is the ratio of the Expenses (in $) in Latvia in 2005 to that in 2006?
Provide a succinct answer. 0.79. What is the ratio of the Expenses (in $) of Madagascar in 2005 to that in 2006?
Ensure brevity in your answer.  0.77. What is the ratio of the Expenses (in $) of Peru in 2005 to that in 2006?
Provide a short and direct response. 0.93. What is the ratio of the Expenses (in $) of Belarus in 2005 to that in 2007?
Keep it short and to the point. 0.7. What is the ratio of the Expenses (in $) of Latvia in 2005 to that in 2007?
Provide a succinct answer. 0.53. What is the ratio of the Expenses (in $) of Madagascar in 2005 to that in 2007?
Keep it short and to the point. 0.64. What is the ratio of the Expenses (in $) of Peru in 2005 to that in 2007?
Your answer should be compact. 0.9. What is the ratio of the Expenses (in $) in Belarus in 2006 to that in 2007?
Your response must be concise. 0.86. What is the ratio of the Expenses (in $) of Latvia in 2006 to that in 2007?
Keep it short and to the point. 0.67. What is the ratio of the Expenses (in $) of Madagascar in 2006 to that in 2007?
Your answer should be very brief. 0.83. What is the ratio of the Expenses (in $) of Peru in 2006 to that in 2007?
Your answer should be very brief. 0.97. What is the difference between the highest and the second highest Expenses (in $) of Belarus?
Offer a very short reply. 5.12e+11. What is the difference between the highest and the second highest Expenses (in $) of Latvia?
Provide a succinct answer. 2.56e+08. What is the difference between the highest and the second highest Expenses (in $) of Madagascar?
Give a very brief answer. 1.21e+11. What is the difference between the highest and the second highest Expenses (in $) of Peru?
Offer a very short reply. 3.02e+08. What is the difference between the highest and the lowest Expenses (in $) of Belarus?
Give a very brief answer. 3.54e+12. What is the difference between the highest and the lowest Expenses (in $) of Latvia?
Provide a succinct answer. 6.15e+08. What is the difference between the highest and the lowest Expenses (in $) of Madagascar?
Keep it short and to the point. 4.84e+11. What is the difference between the highest and the lowest Expenses (in $) of Peru?
Keep it short and to the point. 2.59e+09. 